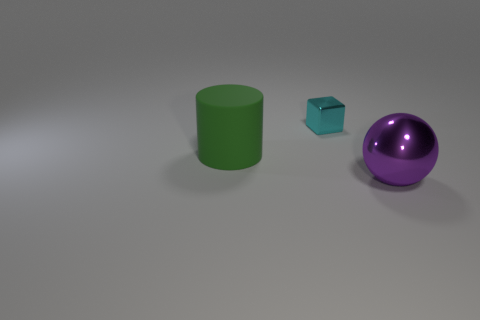Add 3 big metal things. How many objects exist? 6 Subtract all cubes. How many objects are left? 2 Subtract all big cyan matte balls. Subtract all large objects. How many objects are left? 1 Add 1 green matte things. How many green matte things are left? 2 Add 2 small blue rubber objects. How many small blue rubber objects exist? 2 Subtract 0 red cubes. How many objects are left? 3 Subtract all green cylinders. How many red blocks are left? 0 